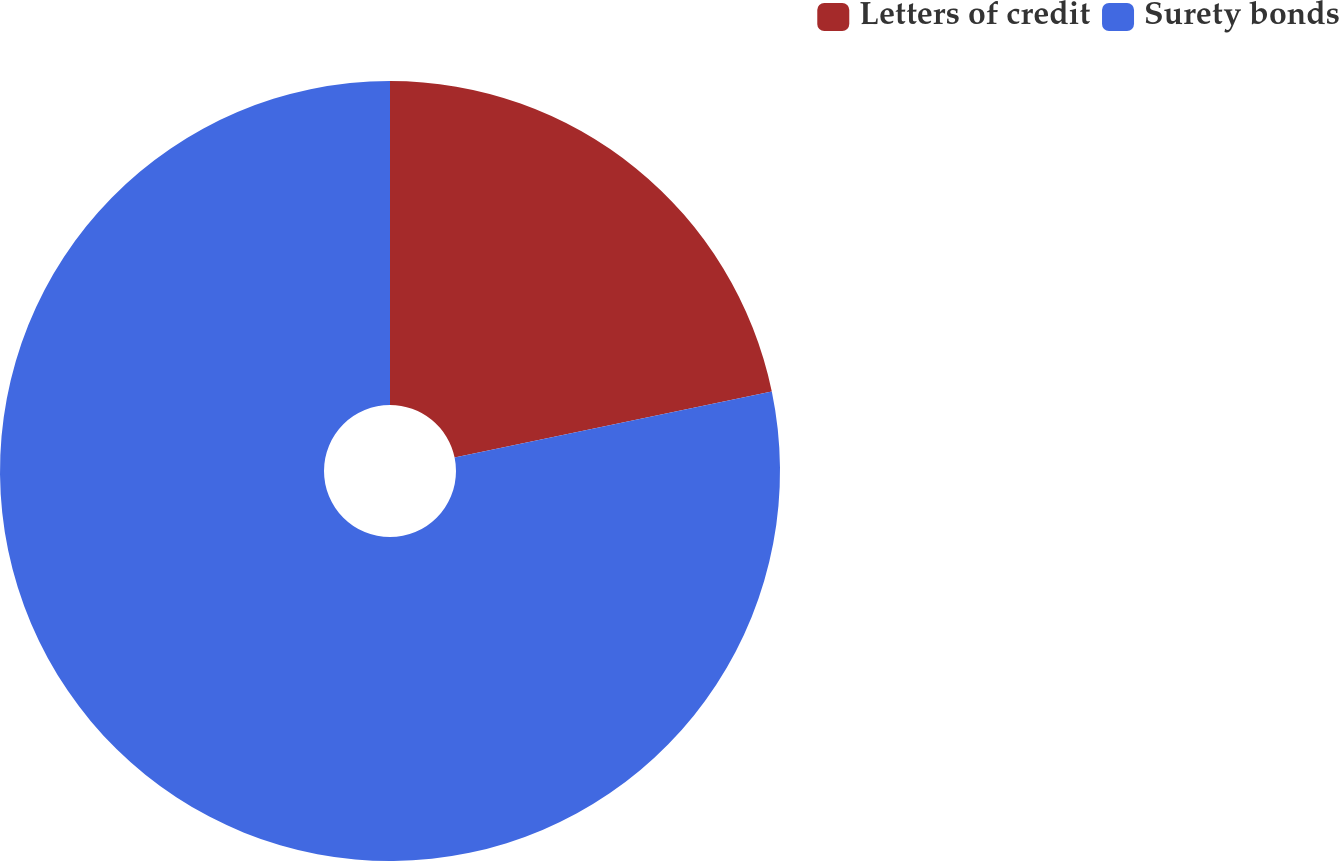<chart> <loc_0><loc_0><loc_500><loc_500><pie_chart><fcel>Letters of credit<fcel>Surety bonds<nl><fcel>21.73%<fcel>78.27%<nl></chart> 